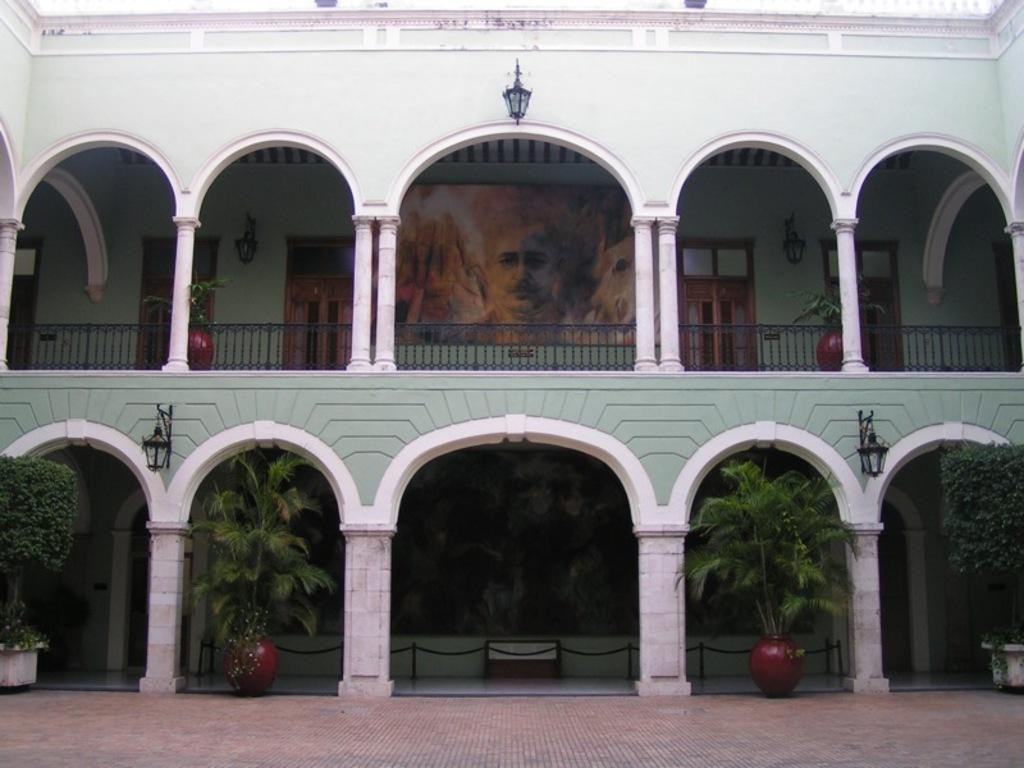What type of structure is visible in the image? There is a building in the image. What are the main features of the building? The building has doors, pillars, and posters. Are there any decorative elements in the image? Yes, there are house plants and lamps in the image. Is there a path visible in the image? Yes, there is a path in the image. What discovery was made while walking along the path in the image? There is no indication of a discovery being made in the image; it simply shows a building, doors, pillars, posters, house plants, lamps, and a path. 